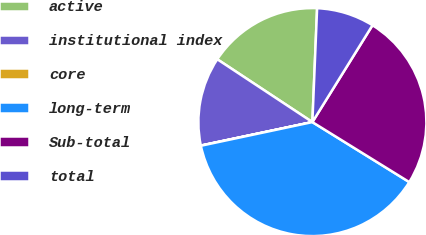Convert chart to OTSL. <chart><loc_0><loc_0><loc_500><loc_500><pie_chart><fcel>active<fcel>institutional index<fcel>core<fcel>long-term<fcel>Sub-total<fcel>total<nl><fcel>16.37%<fcel>12.59%<fcel>0.03%<fcel>37.85%<fcel>24.98%<fcel>8.18%<nl></chart> 